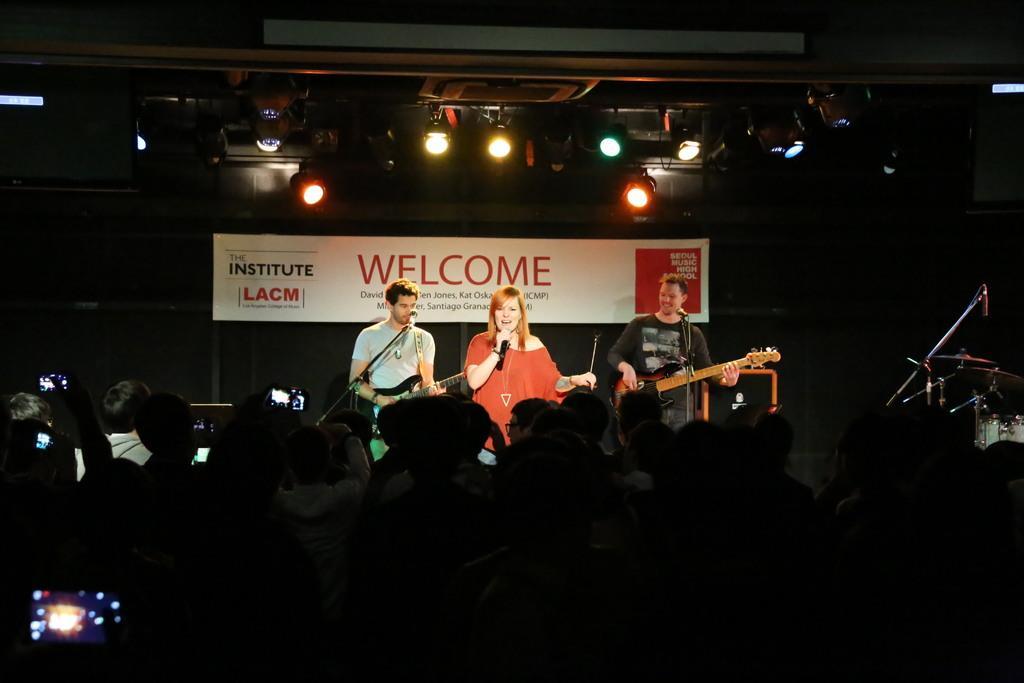Could you give a brief overview of what you see in this image? In this image there is a woman holding a mic is singing, beside the women there are two people standing and playing guitars in front of mics, on the right side of the image there are drums, behind the woman there is a banner, at the top of the image there are lamps, in front of the image there are a few people holding mobiles in their hands. 